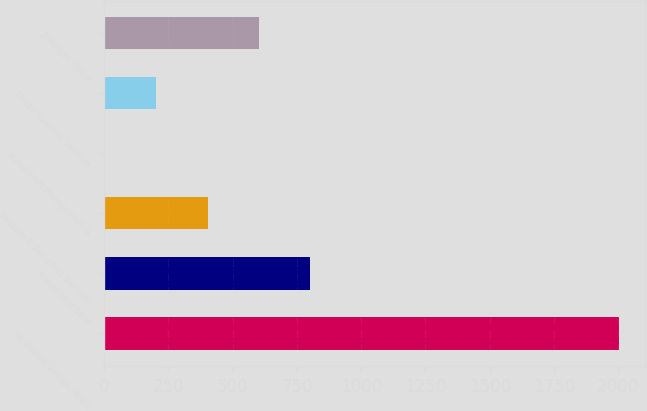Convert chart to OTSL. <chart><loc_0><loc_0><loc_500><loc_500><bar_chart><fcel>(in millions except ratios)<fcel>Investment Bank<fcel>Treasury & Securities Services<fcel>Investment Management &<fcel>Chase Financial Services<fcel>JPMorgan Chase<nl><fcel>2002<fcel>802.6<fcel>402.8<fcel>3<fcel>202.9<fcel>602.7<nl></chart> 